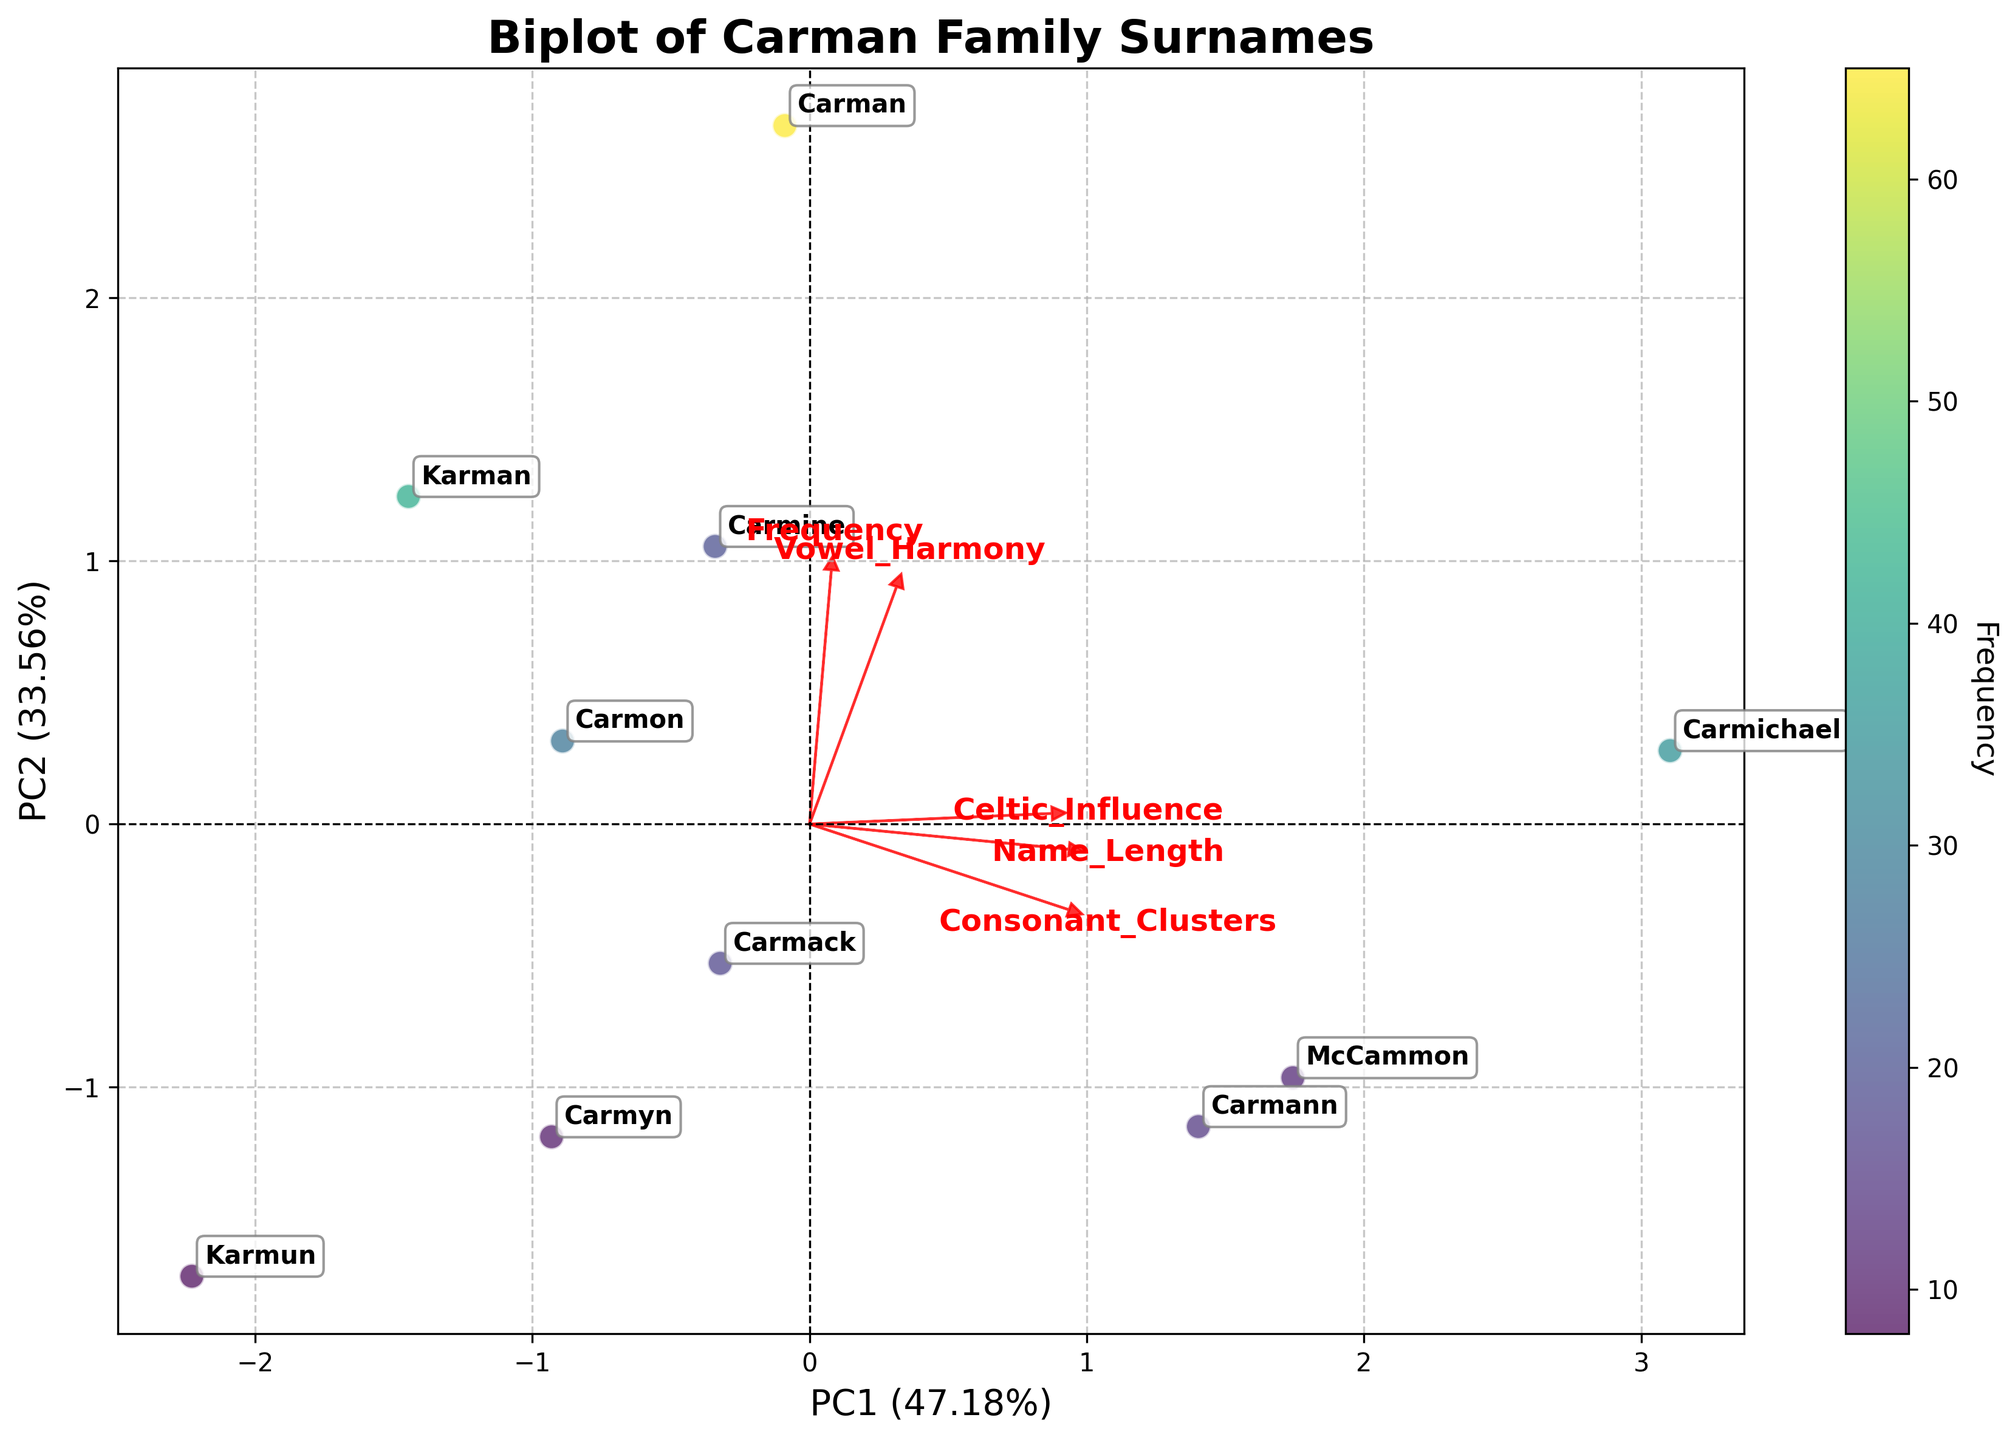What is the title of the figure? The title is located at the top of the figure and is clearly displayed.
Answer: Biplot of Carman Family Surnames Which surname has the highest frequency? By looking at the color density in the scatter plot, the surname with the highest frequency will be the one with the darkest color. Additionally, surnames are annotated, making it easier to identify.
Answer: Carman What does the x-axis represent? The label on the x-axis will tell us what it represents. It is typically aligned horizontally at the bottom of the plot.
Answer: PC1 How many surnames are displayed in the figure? Each data point represents a different surname. By counting the annotated surnames, we can determine the total number.
Answer: 10 Which feature has the largest loading on PC1? The direction and length of the arrows (loadings) indicate their influence on PC1. The feature with the longest arrow along the x-axis has the largest loading.
Answer: Frequency Which surname has the longest name? By looking for the surname annotation located closest to the feature arrow labeled "Name_Length," we can determine which surname has the longest name.
Answer: Carmichael What proportion of the total variance is explained by the first principal component (PC1)? Reading the label on the x-axis will give us the percentage of variance explained by PC1.
Answer: Approximately 41.5% How does the Celtic Influence of "McCammon" compare to that of "Carmon"? Look for the position of the "McCammon" and "Carmon" annotations and compare their location relative to the "Celtic_Influence" arrow. McCammon should be closer to the direction of the arrow indicating a higher value.
Answer: McCammon has a higher Celtic Influence than Carmon Which feature is most correlated with the variance in the second principal component (PC2)? The direction and length of the arrows will show which feature has the largest loading along the y-axis corresponding to PC2. The one pointing mostly in the vertical direction indicates the highest correlation with PC2.
Answer: Name_Length Are "Carmon" and "Carman" similar based on their position in the plot? Check the proximity of "Carmon" and "Carman" annotations on the plot. If they are near each other, it indicates similarity.
Answer: Yes 